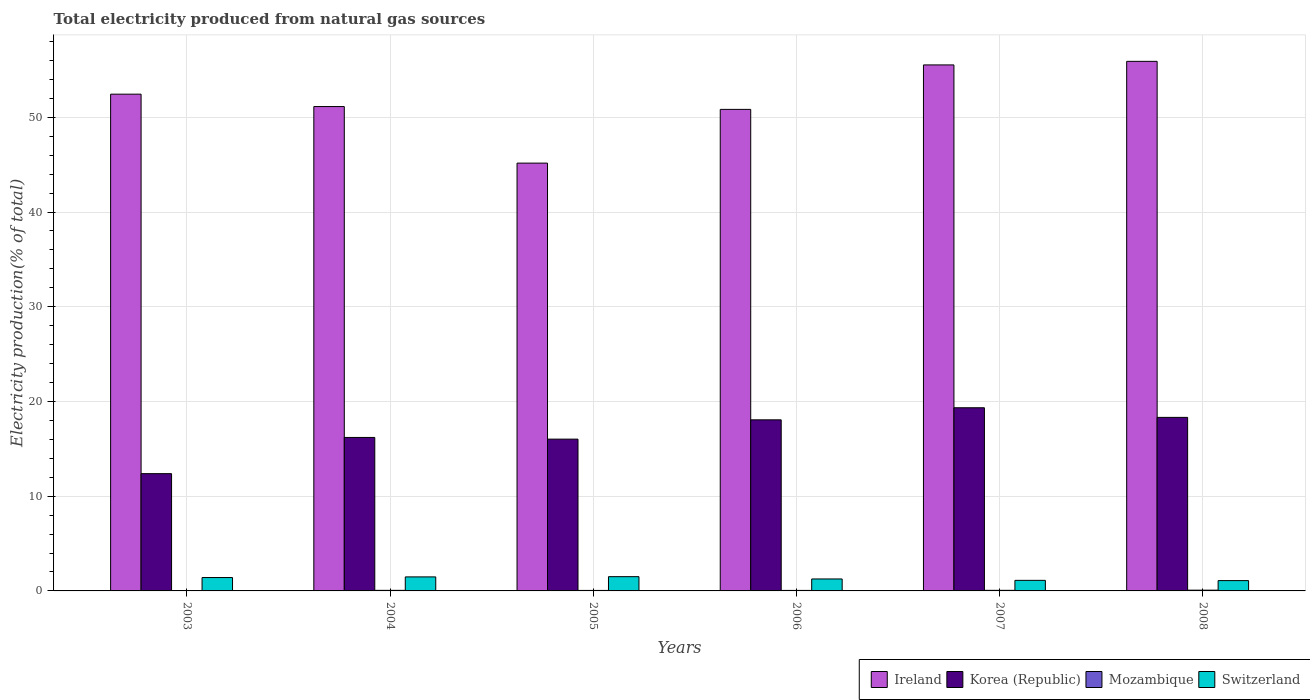How many different coloured bars are there?
Give a very brief answer. 4. What is the label of the 4th group of bars from the left?
Make the answer very short. 2006. In how many cases, is the number of bars for a given year not equal to the number of legend labels?
Ensure brevity in your answer.  0. What is the total electricity produced in Mozambique in 2008?
Your answer should be very brief. 0.08. Across all years, what is the maximum total electricity produced in Mozambique?
Your answer should be very brief. 0.08. Across all years, what is the minimum total electricity produced in Korea (Republic)?
Give a very brief answer. 12.38. What is the total total electricity produced in Ireland in the graph?
Make the answer very short. 311.02. What is the difference between the total electricity produced in Ireland in 2004 and that in 2006?
Offer a terse response. 0.3. What is the difference between the total electricity produced in Korea (Republic) in 2003 and the total electricity produced in Ireland in 2006?
Offer a terse response. -38.46. What is the average total electricity produced in Mozambique per year?
Provide a succinct answer. 0.06. In the year 2005, what is the difference between the total electricity produced in Switzerland and total electricity produced in Korea (Republic)?
Give a very brief answer. -14.52. In how many years, is the total electricity produced in Ireland greater than 42 %?
Provide a short and direct response. 6. What is the ratio of the total electricity produced in Korea (Republic) in 2003 to that in 2005?
Your answer should be compact. 0.77. What is the difference between the highest and the second highest total electricity produced in Ireland?
Ensure brevity in your answer.  0.38. What is the difference between the highest and the lowest total electricity produced in Ireland?
Ensure brevity in your answer.  10.74. Is it the case that in every year, the sum of the total electricity produced in Switzerland and total electricity produced in Ireland is greater than the sum of total electricity produced in Korea (Republic) and total electricity produced in Mozambique?
Offer a terse response. Yes. What does the 1st bar from the left in 2003 represents?
Give a very brief answer. Ireland. What does the 1st bar from the right in 2004 represents?
Offer a terse response. Switzerland. Is it the case that in every year, the sum of the total electricity produced in Korea (Republic) and total electricity produced in Switzerland is greater than the total electricity produced in Mozambique?
Make the answer very short. Yes. How many bars are there?
Give a very brief answer. 24. Does the graph contain grids?
Offer a terse response. Yes. What is the title of the graph?
Make the answer very short. Total electricity produced from natural gas sources. Does "Germany" appear as one of the legend labels in the graph?
Provide a succinct answer. No. What is the label or title of the X-axis?
Make the answer very short. Years. What is the Electricity production(% of total) in Ireland in 2003?
Give a very brief answer. 52.44. What is the Electricity production(% of total) of Korea (Republic) in 2003?
Offer a very short reply. 12.38. What is the Electricity production(% of total) of Mozambique in 2003?
Your answer should be very brief. 0.03. What is the Electricity production(% of total) of Switzerland in 2003?
Provide a succinct answer. 1.41. What is the Electricity production(% of total) of Ireland in 2004?
Offer a very short reply. 51.14. What is the Electricity production(% of total) in Korea (Republic) in 2004?
Give a very brief answer. 16.2. What is the Electricity production(% of total) in Mozambique in 2004?
Keep it short and to the point. 0.06. What is the Electricity production(% of total) in Switzerland in 2004?
Offer a very short reply. 1.48. What is the Electricity production(% of total) in Ireland in 2005?
Provide a short and direct response. 45.17. What is the Electricity production(% of total) in Korea (Republic) in 2005?
Keep it short and to the point. 16.02. What is the Electricity production(% of total) in Mozambique in 2005?
Make the answer very short. 0.05. What is the Electricity production(% of total) in Switzerland in 2005?
Offer a terse response. 1.51. What is the Electricity production(% of total) of Ireland in 2006?
Offer a terse response. 50.84. What is the Electricity production(% of total) of Korea (Republic) in 2006?
Offer a very short reply. 18.06. What is the Electricity production(% of total) of Mozambique in 2006?
Provide a succinct answer. 0.05. What is the Electricity production(% of total) in Switzerland in 2006?
Your response must be concise. 1.26. What is the Electricity production(% of total) in Ireland in 2007?
Your response must be concise. 55.53. What is the Electricity production(% of total) of Korea (Republic) in 2007?
Ensure brevity in your answer.  19.34. What is the Electricity production(% of total) of Mozambique in 2007?
Offer a terse response. 0.06. What is the Electricity production(% of total) in Switzerland in 2007?
Ensure brevity in your answer.  1.12. What is the Electricity production(% of total) in Ireland in 2008?
Offer a terse response. 55.91. What is the Electricity production(% of total) of Korea (Republic) in 2008?
Your answer should be very brief. 18.32. What is the Electricity production(% of total) of Mozambique in 2008?
Give a very brief answer. 0.08. What is the Electricity production(% of total) of Switzerland in 2008?
Keep it short and to the point. 1.09. Across all years, what is the maximum Electricity production(% of total) in Ireland?
Offer a terse response. 55.91. Across all years, what is the maximum Electricity production(% of total) of Korea (Republic)?
Your answer should be compact. 19.34. Across all years, what is the maximum Electricity production(% of total) in Mozambique?
Offer a very short reply. 0.08. Across all years, what is the maximum Electricity production(% of total) of Switzerland?
Keep it short and to the point. 1.51. Across all years, what is the minimum Electricity production(% of total) of Ireland?
Make the answer very short. 45.17. Across all years, what is the minimum Electricity production(% of total) of Korea (Republic)?
Provide a succinct answer. 12.38. Across all years, what is the minimum Electricity production(% of total) of Mozambique?
Ensure brevity in your answer.  0.03. Across all years, what is the minimum Electricity production(% of total) of Switzerland?
Make the answer very short. 1.09. What is the total Electricity production(% of total) in Ireland in the graph?
Give a very brief answer. 311.02. What is the total Electricity production(% of total) of Korea (Republic) in the graph?
Give a very brief answer. 100.33. What is the total Electricity production(% of total) of Mozambique in the graph?
Your answer should be compact. 0.34. What is the total Electricity production(% of total) in Switzerland in the graph?
Your response must be concise. 7.87. What is the difference between the Electricity production(% of total) in Ireland in 2003 and that in 2004?
Offer a terse response. 1.31. What is the difference between the Electricity production(% of total) of Korea (Republic) in 2003 and that in 2004?
Ensure brevity in your answer.  -3.82. What is the difference between the Electricity production(% of total) in Mozambique in 2003 and that in 2004?
Provide a succinct answer. -0.03. What is the difference between the Electricity production(% of total) of Switzerland in 2003 and that in 2004?
Your answer should be very brief. -0.07. What is the difference between the Electricity production(% of total) of Ireland in 2003 and that in 2005?
Your answer should be very brief. 7.28. What is the difference between the Electricity production(% of total) in Korea (Republic) in 2003 and that in 2005?
Make the answer very short. -3.64. What is the difference between the Electricity production(% of total) of Mozambique in 2003 and that in 2005?
Offer a very short reply. -0.03. What is the difference between the Electricity production(% of total) of Switzerland in 2003 and that in 2005?
Keep it short and to the point. -0.09. What is the difference between the Electricity production(% of total) of Ireland in 2003 and that in 2006?
Offer a very short reply. 1.61. What is the difference between the Electricity production(% of total) in Korea (Republic) in 2003 and that in 2006?
Offer a very short reply. -5.68. What is the difference between the Electricity production(% of total) in Mozambique in 2003 and that in 2006?
Your response must be concise. -0.03. What is the difference between the Electricity production(% of total) in Switzerland in 2003 and that in 2006?
Keep it short and to the point. 0.15. What is the difference between the Electricity production(% of total) in Ireland in 2003 and that in 2007?
Your answer should be very brief. -3.09. What is the difference between the Electricity production(% of total) in Korea (Republic) in 2003 and that in 2007?
Offer a very short reply. -6.96. What is the difference between the Electricity production(% of total) in Mozambique in 2003 and that in 2007?
Your answer should be compact. -0.03. What is the difference between the Electricity production(% of total) of Switzerland in 2003 and that in 2007?
Your answer should be compact. 0.3. What is the difference between the Electricity production(% of total) of Ireland in 2003 and that in 2008?
Your answer should be very brief. -3.46. What is the difference between the Electricity production(% of total) in Korea (Republic) in 2003 and that in 2008?
Offer a very short reply. -5.94. What is the difference between the Electricity production(% of total) in Mozambique in 2003 and that in 2008?
Provide a succinct answer. -0.05. What is the difference between the Electricity production(% of total) in Switzerland in 2003 and that in 2008?
Make the answer very short. 0.32. What is the difference between the Electricity production(% of total) of Ireland in 2004 and that in 2005?
Keep it short and to the point. 5.97. What is the difference between the Electricity production(% of total) of Korea (Republic) in 2004 and that in 2005?
Your response must be concise. 0.18. What is the difference between the Electricity production(% of total) of Mozambique in 2004 and that in 2005?
Offer a terse response. 0.01. What is the difference between the Electricity production(% of total) in Switzerland in 2004 and that in 2005?
Your answer should be very brief. -0.03. What is the difference between the Electricity production(% of total) of Ireland in 2004 and that in 2006?
Your response must be concise. 0.3. What is the difference between the Electricity production(% of total) in Korea (Republic) in 2004 and that in 2006?
Give a very brief answer. -1.86. What is the difference between the Electricity production(% of total) of Mozambique in 2004 and that in 2006?
Make the answer very short. 0.01. What is the difference between the Electricity production(% of total) in Switzerland in 2004 and that in 2006?
Offer a terse response. 0.22. What is the difference between the Electricity production(% of total) of Ireland in 2004 and that in 2007?
Offer a very short reply. -4.4. What is the difference between the Electricity production(% of total) in Korea (Republic) in 2004 and that in 2007?
Give a very brief answer. -3.14. What is the difference between the Electricity production(% of total) of Mozambique in 2004 and that in 2007?
Provide a short and direct response. -0. What is the difference between the Electricity production(% of total) of Switzerland in 2004 and that in 2007?
Keep it short and to the point. 0.36. What is the difference between the Electricity production(% of total) of Ireland in 2004 and that in 2008?
Provide a short and direct response. -4.77. What is the difference between the Electricity production(% of total) in Korea (Republic) in 2004 and that in 2008?
Offer a very short reply. -2.12. What is the difference between the Electricity production(% of total) of Mozambique in 2004 and that in 2008?
Keep it short and to the point. -0.02. What is the difference between the Electricity production(% of total) in Switzerland in 2004 and that in 2008?
Provide a succinct answer. 0.39. What is the difference between the Electricity production(% of total) in Ireland in 2005 and that in 2006?
Your answer should be compact. -5.67. What is the difference between the Electricity production(% of total) in Korea (Republic) in 2005 and that in 2006?
Offer a terse response. -2.04. What is the difference between the Electricity production(% of total) in Mozambique in 2005 and that in 2006?
Make the answer very short. -0. What is the difference between the Electricity production(% of total) of Switzerland in 2005 and that in 2006?
Provide a short and direct response. 0.24. What is the difference between the Electricity production(% of total) in Ireland in 2005 and that in 2007?
Your response must be concise. -10.37. What is the difference between the Electricity production(% of total) of Korea (Republic) in 2005 and that in 2007?
Keep it short and to the point. -3.31. What is the difference between the Electricity production(% of total) in Mozambique in 2005 and that in 2007?
Ensure brevity in your answer.  -0.01. What is the difference between the Electricity production(% of total) in Switzerland in 2005 and that in 2007?
Offer a very short reply. 0.39. What is the difference between the Electricity production(% of total) in Ireland in 2005 and that in 2008?
Provide a short and direct response. -10.74. What is the difference between the Electricity production(% of total) in Korea (Republic) in 2005 and that in 2008?
Make the answer very short. -2.3. What is the difference between the Electricity production(% of total) of Mozambique in 2005 and that in 2008?
Your response must be concise. -0.03. What is the difference between the Electricity production(% of total) of Switzerland in 2005 and that in 2008?
Provide a succinct answer. 0.42. What is the difference between the Electricity production(% of total) in Ireland in 2006 and that in 2007?
Keep it short and to the point. -4.69. What is the difference between the Electricity production(% of total) in Korea (Republic) in 2006 and that in 2007?
Offer a very short reply. -1.28. What is the difference between the Electricity production(% of total) of Mozambique in 2006 and that in 2007?
Provide a short and direct response. -0.01. What is the difference between the Electricity production(% of total) of Switzerland in 2006 and that in 2007?
Offer a very short reply. 0.15. What is the difference between the Electricity production(% of total) in Ireland in 2006 and that in 2008?
Offer a terse response. -5.07. What is the difference between the Electricity production(% of total) in Korea (Republic) in 2006 and that in 2008?
Your answer should be compact. -0.26. What is the difference between the Electricity production(% of total) of Mozambique in 2006 and that in 2008?
Offer a very short reply. -0.03. What is the difference between the Electricity production(% of total) in Switzerland in 2006 and that in 2008?
Ensure brevity in your answer.  0.17. What is the difference between the Electricity production(% of total) in Ireland in 2007 and that in 2008?
Give a very brief answer. -0.38. What is the difference between the Electricity production(% of total) in Korea (Republic) in 2007 and that in 2008?
Offer a terse response. 1.02. What is the difference between the Electricity production(% of total) of Mozambique in 2007 and that in 2008?
Provide a short and direct response. -0.02. What is the difference between the Electricity production(% of total) of Switzerland in 2007 and that in 2008?
Offer a terse response. 0.03. What is the difference between the Electricity production(% of total) of Ireland in 2003 and the Electricity production(% of total) of Korea (Republic) in 2004?
Give a very brief answer. 36.24. What is the difference between the Electricity production(% of total) of Ireland in 2003 and the Electricity production(% of total) of Mozambique in 2004?
Provide a succinct answer. 52.38. What is the difference between the Electricity production(% of total) of Ireland in 2003 and the Electricity production(% of total) of Switzerland in 2004?
Make the answer very short. 50.96. What is the difference between the Electricity production(% of total) of Korea (Republic) in 2003 and the Electricity production(% of total) of Mozambique in 2004?
Keep it short and to the point. 12.32. What is the difference between the Electricity production(% of total) of Korea (Republic) in 2003 and the Electricity production(% of total) of Switzerland in 2004?
Offer a very short reply. 10.9. What is the difference between the Electricity production(% of total) in Mozambique in 2003 and the Electricity production(% of total) in Switzerland in 2004?
Your answer should be compact. -1.45. What is the difference between the Electricity production(% of total) of Ireland in 2003 and the Electricity production(% of total) of Korea (Republic) in 2005?
Give a very brief answer. 36.42. What is the difference between the Electricity production(% of total) in Ireland in 2003 and the Electricity production(% of total) in Mozambique in 2005?
Your answer should be compact. 52.39. What is the difference between the Electricity production(% of total) of Ireland in 2003 and the Electricity production(% of total) of Switzerland in 2005?
Provide a succinct answer. 50.94. What is the difference between the Electricity production(% of total) of Korea (Republic) in 2003 and the Electricity production(% of total) of Mozambique in 2005?
Give a very brief answer. 12.33. What is the difference between the Electricity production(% of total) of Korea (Republic) in 2003 and the Electricity production(% of total) of Switzerland in 2005?
Your response must be concise. 10.88. What is the difference between the Electricity production(% of total) in Mozambique in 2003 and the Electricity production(% of total) in Switzerland in 2005?
Your answer should be very brief. -1.48. What is the difference between the Electricity production(% of total) in Ireland in 2003 and the Electricity production(% of total) in Korea (Republic) in 2006?
Give a very brief answer. 34.38. What is the difference between the Electricity production(% of total) of Ireland in 2003 and the Electricity production(% of total) of Mozambique in 2006?
Make the answer very short. 52.39. What is the difference between the Electricity production(% of total) in Ireland in 2003 and the Electricity production(% of total) in Switzerland in 2006?
Your answer should be compact. 51.18. What is the difference between the Electricity production(% of total) of Korea (Republic) in 2003 and the Electricity production(% of total) of Mozambique in 2006?
Make the answer very short. 12.33. What is the difference between the Electricity production(% of total) in Korea (Republic) in 2003 and the Electricity production(% of total) in Switzerland in 2006?
Your response must be concise. 11.12. What is the difference between the Electricity production(% of total) of Mozambique in 2003 and the Electricity production(% of total) of Switzerland in 2006?
Offer a very short reply. -1.24. What is the difference between the Electricity production(% of total) of Ireland in 2003 and the Electricity production(% of total) of Korea (Republic) in 2007?
Your answer should be compact. 33.11. What is the difference between the Electricity production(% of total) in Ireland in 2003 and the Electricity production(% of total) in Mozambique in 2007?
Offer a terse response. 52.38. What is the difference between the Electricity production(% of total) of Ireland in 2003 and the Electricity production(% of total) of Switzerland in 2007?
Keep it short and to the point. 51.33. What is the difference between the Electricity production(% of total) of Korea (Republic) in 2003 and the Electricity production(% of total) of Mozambique in 2007?
Offer a very short reply. 12.32. What is the difference between the Electricity production(% of total) of Korea (Republic) in 2003 and the Electricity production(% of total) of Switzerland in 2007?
Give a very brief answer. 11.27. What is the difference between the Electricity production(% of total) in Mozambique in 2003 and the Electricity production(% of total) in Switzerland in 2007?
Your answer should be very brief. -1.09. What is the difference between the Electricity production(% of total) in Ireland in 2003 and the Electricity production(% of total) in Korea (Republic) in 2008?
Ensure brevity in your answer.  34.12. What is the difference between the Electricity production(% of total) of Ireland in 2003 and the Electricity production(% of total) of Mozambique in 2008?
Your answer should be compact. 52.36. What is the difference between the Electricity production(% of total) in Ireland in 2003 and the Electricity production(% of total) in Switzerland in 2008?
Offer a terse response. 51.35. What is the difference between the Electricity production(% of total) in Korea (Republic) in 2003 and the Electricity production(% of total) in Mozambique in 2008?
Make the answer very short. 12.3. What is the difference between the Electricity production(% of total) in Korea (Republic) in 2003 and the Electricity production(% of total) in Switzerland in 2008?
Your answer should be very brief. 11.29. What is the difference between the Electricity production(% of total) of Mozambique in 2003 and the Electricity production(% of total) of Switzerland in 2008?
Give a very brief answer. -1.06. What is the difference between the Electricity production(% of total) in Ireland in 2004 and the Electricity production(% of total) in Korea (Republic) in 2005?
Keep it short and to the point. 35.11. What is the difference between the Electricity production(% of total) of Ireland in 2004 and the Electricity production(% of total) of Mozambique in 2005?
Offer a terse response. 51.08. What is the difference between the Electricity production(% of total) in Ireland in 2004 and the Electricity production(% of total) in Switzerland in 2005?
Your response must be concise. 49.63. What is the difference between the Electricity production(% of total) of Korea (Republic) in 2004 and the Electricity production(% of total) of Mozambique in 2005?
Make the answer very short. 16.15. What is the difference between the Electricity production(% of total) of Korea (Republic) in 2004 and the Electricity production(% of total) of Switzerland in 2005?
Provide a succinct answer. 14.7. What is the difference between the Electricity production(% of total) of Mozambique in 2004 and the Electricity production(% of total) of Switzerland in 2005?
Offer a terse response. -1.45. What is the difference between the Electricity production(% of total) in Ireland in 2004 and the Electricity production(% of total) in Korea (Republic) in 2006?
Keep it short and to the point. 33.07. What is the difference between the Electricity production(% of total) in Ireland in 2004 and the Electricity production(% of total) in Mozambique in 2006?
Give a very brief answer. 51.08. What is the difference between the Electricity production(% of total) of Ireland in 2004 and the Electricity production(% of total) of Switzerland in 2006?
Provide a succinct answer. 49.87. What is the difference between the Electricity production(% of total) in Korea (Republic) in 2004 and the Electricity production(% of total) in Mozambique in 2006?
Make the answer very short. 16.15. What is the difference between the Electricity production(% of total) in Korea (Republic) in 2004 and the Electricity production(% of total) in Switzerland in 2006?
Provide a succinct answer. 14.94. What is the difference between the Electricity production(% of total) in Mozambique in 2004 and the Electricity production(% of total) in Switzerland in 2006?
Make the answer very short. -1.2. What is the difference between the Electricity production(% of total) in Ireland in 2004 and the Electricity production(% of total) in Korea (Republic) in 2007?
Provide a succinct answer. 31.8. What is the difference between the Electricity production(% of total) of Ireland in 2004 and the Electricity production(% of total) of Mozambique in 2007?
Make the answer very short. 51.07. What is the difference between the Electricity production(% of total) of Ireland in 2004 and the Electricity production(% of total) of Switzerland in 2007?
Provide a short and direct response. 50.02. What is the difference between the Electricity production(% of total) in Korea (Republic) in 2004 and the Electricity production(% of total) in Mozambique in 2007?
Give a very brief answer. 16.14. What is the difference between the Electricity production(% of total) of Korea (Republic) in 2004 and the Electricity production(% of total) of Switzerland in 2007?
Your answer should be compact. 15.09. What is the difference between the Electricity production(% of total) of Mozambique in 2004 and the Electricity production(% of total) of Switzerland in 2007?
Provide a succinct answer. -1.06. What is the difference between the Electricity production(% of total) of Ireland in 2004 and the Electricity production(% of total) of Korea (Republic) in 2008?
Give a very brief answer. 32.82. What is the difference between the Electricity production(% of total) in Ireland in 2004 and the Electricity production(% of total) in Mozambique in 2008?
Offer a very short reply. 51.06. What is the difference between the Electricity production(% of total) in Ireland in 2004 and the Electricity production(% of total) in Switzerland in 2008?
Make the answer very short. 50.05. What is the difference between the Electricity production(% of total) of Korea (Republic) in 2004 and the Electricity production(% of total) of Mozambique in 2008?
Provide a succinct answer. 16.12. What is the difference between the Electricity production(% of total) of Korea (Republic) in 2004 and the Electricity production(% of total) of Switzerland in 2008?
Your answer should be very brief. 15.11. What is the difference between the Electricity production(% of total) of Mozambique in 2004 and the Electricity production(% of total) of Switzerland in 2008?
Keep it short and to the point. -1.03. What is the difference between the Electricity production(% of total) of Ireland in 2005 and the Electricity production(% of total) of Korea (Republic) in 2006?
Offer a very short reply. 27.1. What is the difference between the Electricity production(% of total) of Ireland in 2005 and the Electricity production(% of total) of Mozambique in 2006?
Your answer should be compact. 45.11. What is the difference between the Electricity production(% of total) in Ireland in 2005 and the Electricity production(% of total) in Switzerland in 2006?
Ensure brevity in your answer.  43.9. What is the difference between the Electricity production(% of total) of Korea (Republic) in 2005 and the Electricity production(% of total) of Mozambique in 2006?
Offer a terse response. 15.97. What is the difference between the Electricity production(% of total) of Korea (Republic) in 2005 and the Electricity production(% of total) of Switzerland in 2006?
Keep it short and to the point. 14.76. What is the difference between the Electricity production(% of total) in Mozambique in 2005 and the Electricity production(% of total) in Switzerland in 2006?
Make the answer very short. -1.21. What is the difference between the Electricity production(% of total) of Ireland in 2005 and the Electricity production(% of total) of Korea (Republic) in 2007?
Your answer should be very brief. 25.83. What is the difference between the Electricity production(% of total) of Ireland in 2005 and the Electricity production(% of total) of Mozambique in 2007?
Offer a very short reply. 45.1. What is the difference between the Electricity production(% of total) in Ireland in 2005 and the Electricity production(% of total) in Switzerland in 2007?
Your answer should be very brief. 44.05. What is the difference between the Electricity production(% of total) in Korea (Republic) in 2005 and the Electricity production(% of total) in Mozambique in 2007?
Your response must be concise. 15.96. What is the difference between the Electricity production(% of total) in Korea (Republic) in 2005 and the Electricity production(% of total) in Switzerland in 2007?
Your answer should be compact. 14.91. What is the difference between the Electricity production(% of total) of Mozambique in 2005 and the Electricity production(% of total) of Switzerland in 2007?
Offer a very short reply. -1.06. What is the difference between the Electricity production(% of total) of Ireland in 2005 and the Electricity production(% of total) of Korea (Republic) in 2008?
Your response must be concise. 26.84. What is the difference between the Electricity production(% of total) in Ireland in 2005 and the Electricity production(% of total) in Mozambique in 2008?
Provide a short and direct response. 45.09. What is the difference between the Electricity production(% of total) in Ireland in 2005 and the Electricity production(% of total) in Switzerland in 2008?
Keep it short and to the point. 44.08. What is the difference between the Electricity production(% of total) of Korea (Republic) in 2005 and the Electricity production(% of total) of Mozambique in 2008?
Make the answer very short. 15.94. What is the difference between the Electricity production(% of total) of Korea (Republic) in 2005 and the Electricity production(% of total) of Switzerland in 2008?
Give a very brief answer. 14.94. What is the difference between the Electricity production(% of total) of Mozambique in 2005 and the Electricity production(% of total) of Switzerland in 2008?
Provide a short and direct response. -1.04. What is the difference between the Electricity production(% of total) in Ireland in 2006 and the Electricity production(% of total) in Korea (Republic) in 2007?
Your answer should be compact. 31.5. What is the difference between the Electricity production(% of total) in Ireland in 2006 and the Electricity production(% of total) in Mozambique in 2007?
Your response must be concise. 50.77. What is the difference between the Electricity production(% of total) in Ireland in 2006 and the Electricity production(% of total) in Switzerland in 2007?
Offer a very short reply. 49.72. What is the difference between the Electricity production(% of total) in Korea (Republic) in 2006 and the Electricity production(% of total) in Mozambique in 2007?
Offer a very short reply. 18. What is the difference between the Electricity production(% of total) in Korea (Republic) in 2006 and the Electricity production(% of total) in Switzerland in 2007?
Give a very brief answer. 16.95. What is the difference between the Electricity production(% of total) of Mozambique in 2006 and the Electricity production(% of total) of Switzerland in 2007?
Provide a short and direct response. -1.06. What is the difference between the Electricity production(% of total) in Ireland in 2006 and the Electricity production(% of total) in Korea (Republic) in 2008?
Provide a short and direct response. 32.52. What is the difference between the Electricity production(% of total) in Ireland in 2006 and the Electricity production(% of total) in Mozambique in 2008?
Provide a short and direct response. 50.76. What is the difference between the Electricity production(% of total) in Ireland in 2006 and the Electricity production(% of total) in Switzerland in 2008?
Give a very brief answer. 49.75. What is the difference between the Electricity production(% of total) in Korea (Republic) in 2006 and the Electricity production(% of total) in Mozambique in 2008?
Offer a very short reply. 17.98. What is the difference between the Electricity production(% of total) of Korea (Republic) in 2006 and the Electricity production(% of total) of Switzerland in 2008?
Your answer should be very brief. 16.97. What is the difference between the Electricity production(% of total) of Mozambique in 2006 and the Electricity production(% of total) of Switzerland in 2008?
Your answer should be compact. -1.03. What is the difference between the Electricity production(% of total) in Ireland in 2007 and the Electricity production(% of total) in Korea (Republic) in 2008?
Provide a succinct answer. 37.21. What is the difference between the Electricity production(% of total) in Ireland in 2007 and the Electricity production(% of total) in Mozambique in 2008?
Give a very brief answer. 55.45. What is the difference between the Electricity production(% of total) of Ireland in 2007 and the Electricity production(% of total) of Switzerland in 2008?
Keep it short and to the point. 54.44. What is the difference between the Electricity production(% of total) in Korea (Republic) in 2007 and the Electricity production(% of total) in Mozambique in 2008?
Provide a short and direct response. 19.26. What is the difference between the Electricity production(% of total) in Korea (Republic) in 2007 and the Electricity production(% of total) in Switzerland in 2008?
Provide a succinct answer. 18.25. What is the difference between the Electricity production(% of total) of Mozambique in 2007 and the Electricity production(% of total) of Switzerland in 2008?
Provide a short and direct response. -1.03. What is the average Electricity production(% of total) of Ireland per year?
Your answer should be very brief. 51.84. What is the average Electricity production(% of total) in Korea (Republic) per year?
Give a very brief answer. 16.72. What is the average Electricity production(% of total) in Mozambique per year?
Your response must be concise. 0.06. What is the average Electricity production(% of total) of Switzerland per year?
Offer a very short reply. 1.31. In the year 2003, what is the difference between the Electricity production(% of total) in Ireland and Electricity production(% of total) in Korea (Republic)?
Give a very brief answer. 40.06. In the year 2003, what is the difference between the Electricity production(% of total) in Ireland and Electricity production(% of total) in Mozambique?
Provide a succinct answer. 52.42. In the year 2003, what is the difference between the Electricity production(% of total) in Ireland and Electricity production(% of total) in Switzerland?
Ensure brevity in your answer.  51.03. In the year 2003, what is the difference between the Electricity production(% of total) of Korea (Republic) and Electricity production(% of total) of Mozambique?
Make the answer very short. 12.35. In the year 2003, what is the difference between the Electricity production(% of total) of Korea (Republic) and Electricity production(% of total) of Switzerland?
Give a very brief answer. 10.97. In the year 2003, what is the difference between the Electricity production(% of total) of Mozambique and Electricity production(% of total) of Switzerland?
Ensure brevity in your answer.  -1.39. In the year 2004, what is the difference between the Electricity production(% of total) of Ireland and Electricity production(% of total) of Korea (Republic)?
Offer a terse response. 34.93. In the year 2004, what is the difference between the Electricity production(% of total) of Ireland and Electricity production(% of total) of Mozambique?
Make the answer very short. 51.08. In the year 2004, what is the difference between the Electricity production(% of total) in Ireland and Electricity production(% of total) in Switzerland?
Offer a terse response. 49.66. In the year 2004, what is the difference between the Electricity production(% of total) of Korea (Republic) and Electricity production(% of total) of Mozambique?
Ensure brevity in your answer.  16.14. In the year 2004, what is the difference between the Electricity production(% of total) in Korea (Republic) and Electricity production(% of total) in Switzerland?
Your response must be concise. 14.72. In the year 2004, what is the difference between the Electricity production(% of total) of Mozambique and Electricity production(% of total) of Switzerland?
Your answer should be compact. -1.42. In the year 2005, what is the difference between the Electricity production(% of total) in Ireland and Electricity production(% of total) in Korea (Republic)?
Provide a succinct answer. 29.14. In the year 2005, what is the difference between the Electricity production(% of total) of Ireland and Electricity production(% of total) of Mozambique?
Offer a terse response. 45.11. In the year 2005, what is the difference between the Electricity production(% of total) in Ireland and Electricity production(% of total) in Switzerland?
Provide a succinct answer. 43.66. In the year 2005, what is the difference between the Electricity production(% of total) of Korea (Republic) and Electricity production(% of total) of Mozambique?
Your answer should be compact. 15.97. In the year 2005, what is the difference between the Electricity production(% of total) in Korea (Republic) and Electricity production(% of total) in Switzerland?
Offer a terse response. 14.52. In the year 2005, what is the difference between the Electricity production(% of total) in Mozambique and Electricity production(% of total) in Switzerland?
Give a very brief answer. -1.45. In the year 2006, what is the difference between the Electricity production(% of total) in Ireland and Electricity production(% of total) in Korea (Republic)?
Ensure brevity in your answer.  32.78. In the year 2006, what is the difference between the Electricity production(% of total) of Ireland and Electricity production(% of total) of Mozambique?
Offer a very short reply. 50.78. In the year 2006, what is the difference between the Electricity production(% of total) in Ireland and Electricity production(% of total) in Switzerland?
Give a very brief answer. 49.57. In the year 2006, what is the difference between the Electricity production(% of total) in Korea (Republic) and Electricity production(% of total) in Mozambique?
Provide a succinct answer. 18.01. In the year 2006, what is the difference between the Electricity production(% of total) of Korea (Republic) and Electricity production(% of total) of Switzerland?
Offer a very short reply. 16.8. In the year 2006, what is the difference between the Electricity production(% of total) of Mozambique and Electricity production(% of total) of Switzerland?
Your answer should be compact. -1.21. In the year 2007, what is the difference between the Electricity production(% of total) in Ireland and Electricity production(% of total) in Korea (Republic)?
Your response must be concise. 36.19. In the year 2007, what is the difference between the Electricity production(% of total) in Ireland and Electricity production(% of total) in Mozambique?
Ensure brevity in your answer.  55.47. In the year 2007, what is the difference between the Electricity production(% of total) in Ireland and Electricity production(% of total) in Switzerland?
Your answer should be very brief. 54.42. In the year 2007, what is the difference between the Electricity production(% of total) in Korea (Republic) and Electricity production(% of total) in Mozambique?
Your answer should be compact. 19.28. In the year 2007, what is the difference between the Electricity production(% of total) in Korea (Republic) and Electricity production(% of total) in Switzerland?
Make the answer very short. 18.22. In the year 2007, what is the difference between the Electricity production(% of total) in Mozambique and Electricity production(% of total) in Switzerland?
Provide a succinct answer. -1.05. In the year 2008, what is the difference between the Electricity production(% of total) of Ireland and Electricity production(% of total) of Korea (Republic)?
Keep it short and to the point. 37.59. In the year 2008, what is the difference between the Electricity production(% of total) in Ireland and Electricity production(% of total) in Mozambique?
Provide a short and direct response. 55.83. In the year 2008, what is the difference between the Electricity production(% of total) of Ireland and Electricity production(% of total) of Switzerland?
Your answer should be compact. 54.82. In the year 2008, what is the difference between the Electricity production(% of total) in Korea (Republic) and Electricity production(% of total) in Mozambique?
Provide a succinct answer. 18.24. In the year 2008, what is the difference between the Electricity production(% of total) in Korea (Republic) and Electricity production(% of total) in Switzerland?
Ensure brevity in your answer.  17.23. In the year 2008, what is the difference between the Electricity production(% of total) in Mozambique and Electricity production(% of total) in Switzerland?
Offer a terse response. -1.01. What is the ratio of the Electricity production(% of total) in Ireland in 2003 to that in 2004?
Offer a terse response. 1.03. What is the ratio of the Electricity production(% of total) in Korea (Republic) in 2003 to that in 2004?
Your response must be concise. 0.76. What is the ratio of the Electricity production(% of total) in Mozambique in 2003 to that in 2004?
Keep it short and to the point. 0.46. What is the ratio of the Electricity production(% of total) in Switzerland in 2003 to that in 2004?
Keep it short and to the point. 0.95. What is the ratio of the Electricity production(% of total) of Ireland in 2003 to that in 2005?
Your response must be concise. 1.16. What is the ratio of the Electricity production(% of total) in Korea (Republic) in 2003 to that in 2005?
Your answer should be compact. 0.77. What is the ratio of the Electricity production(% of total) of Mozambique in 2003 to that in 2005?
Keep it short and to the point. 0.52. What is the ratio of the Electricity production(% of total) in Switzerland in 2003 to that in 2005?
Make the answer very short. 0.94. What is the ratio of the Electricity production(% of total) in Ireland in 2003 to that in 2006?
Your answer should be very brief. 1.03. What is the ratio of the Electricity production(% of total) in Korea (Republic) in 2003 to that in 2006?
Ensure brevity in your answer.  0.69. What is the ratio of the Electricity production(% of total) of Mozambique in 2003 to that in 2006?
Provide a short and direct response. 0.51. What is the ratio of the Electricity production(% of total) in Switzerland in 2003 to that in 2006?
Provide a short and direct response. 1.12. What is the ratio of the Electricity production(% of total) in Ireland in 2003 to that in 2007?
Your answer should be very brief. 0.94. What is the ratio of the Electricity production(% of total) in Korea (Republic) in 2003 to that in 2007?
Your answer should be compact. 0.64. What is the ratio of the Electricity production(% of total) in Mozambique in 2003 to that in 2007?
Your answer should be very brief. 0.44. What is the ratio of the Electricity production(% of total) in Switzerland in 2003 to that in 2007?
Your response must be concise. 1.27. What is the ratio of the Electricity production(% of total) in Ireland in 2003 to that in 2008?
Make the answer very short. 0.94. What is the ratio of the Electricity production(% of total) in Korea (Republic) in 2003 to that in 2008?
Offer a terse response. 0.68. What is the ratio of the Electricity production(% of total) in Mozambique in 2003 to that in 2008?
Your response must be concise. 0.35. What is the ratio of the Electricity production(% of total) of Switzerland in 2003 to that in 2008?
Your answer should be very brief. 1.3. What is the ratio of the Electricity production(% of total) in Ireland in 2004 to that in 2005?
Your answer should be compact. 1.13. What is the ratio of the Electricity production(% of total) in Korea (Republic) in 2004 to that in 2005?
Offer a terse response. 1.01. What is the ratio of the Electricity production(% of total) in Mozambique in 2004 to that in 2005?
Keep it short and to the point. 1.13. What is the ratio of the Electricity production(% of total) of Switzerland in 2004 to that in 2005?
Your answer should be compact. 0.98. What is the ratio of the Electricity production(% of total) in Ireland in 2004 to that in 2006?
Ensure brevity in your answer.  1.01. What is the ratio of the Electricity production(% of total) in Korea (Republic) in 2004 to that in 2006?
Your response must be concise. 0.9. What is the ratio of the Electricity production(% of total) in Mozambique in 2004 to that in 2006?
Keep it short and to the point. 1.1. What is the ratio of the Electricity production(% of total) of Switzerland in 2004 to that in 2006?
Your answer should be very brief. 1.17. What is the ratio of the Electricity production(% of total) in Ireland in 2004 to that in 2007?
Provide a succinct answer. 0.92. What is the ratio of the Electricity production(% of total) in Korea (Republic) in 2004 to that in 2007?
Offer a terse response. 0.84. What is the ratio of the Electricity production(% of total) of Mozambique in 2004 to that in 2007?
Keep it short and to the point. 0.96. What is the ratio of the Electricity production(% of total) of Switzerland in 2004 to that in 2007?
Provide a succinct answer. 1.33. What is the ratio of the Electricity production(% of total) in Ireland in 2004 to that in 2008?
Your answer should be compact. 0.91. What is the ratio of the Electricity production(% of total) of Korea (Republic) in 2004 to that in 2008?
Give a very brief answer. 0.88. What is the ratio of the Electricity production(% of total) of Mozambique in 2004 to that in 2008?
Provide a succinct answer. 0.75. What is the ratio of the Electricity production(% of total) of Switzerland in 2004 to that in 2008?
Offer a terse response. 1.36. What is the ratio of the Electricity production(% of total) of Ireland in 2005 to that in 2006?
Offer a very short reply. 0.89. What is the ratio of the Electricity production(% of total) of Korea (Republic) in 2005 to that in 2006?
Offer a terse response. 0.89. What is the ratio of the Electricity production(% of total) in Mozambique in 2005 to that in 2006?
Provide a short and direct response. 0.97. What is the ratio of the Electricity production(% of total) of Switzerland in 2005 to that in 2006?
Offer a terse response. 1.19. What is the ratio of the Electricity production(% of total) in Ireland in 2005 to that in 2007?
Offer a terse response. 0.81. What is the ratio of the Electricity production(% of total) of Korea (Republic) in 2005 to that in 2007?
Keep it short and to the point. 0.83. What is the ratio of the Electricity production(% of total) in Mozambique in 2005 to that in 2007?
Offer a very short reply. 0.85. What is the ratio of the Electricity production(% of total) in Switzerland in 2005 to that in 2007?
Provide a short and direct response. 1.35. What is the ratio of the Electricity production(% of total) in Ireland in 2005 to that in 2008?
Provide a short and direct response. 0.81. What is the ratio of the Electricity production(% of total) in Korea (Republic) in 2005 to that in 2008?
Make the answer very short. 0.87. What is the ratio of the Electricity production(% of total) in Mozambique in 2005 to that in 2008?
Give a very brief answer. 0.66. What is the ratio of the Electricity production(% of total) of Switzerland in 2005 to that in 2008?
Your answer should be compact. 1.38. What is the ratio of the Electricity production(% of total) in Ireland in 2006 to that in 2007?
Make the answer very short. 0.92. What is the ratio of the Electricity production(% of total) in Korea (Republic) in 2006 to that in 2007?
Provide a short and direct response. 0.93. What is the ratio of the Electricity production(% of total) of Mozambique in 2006 to that in 2007?
Provide a succinct answer. 0.87. What is the ratio of the Electricity production(% of total) of Switzerland in 2006 to that in 2007?
Provide a short and direct response. 1.13. What is the ratio of the Electricity production(% of total) of Ireland in 2006 to that in 2008?
Make the answer very short. 0.91. What is the ratio of the Electricity production(% of total) in Korea (Republic) in 2006 to that in 2008?
Your response must be concise. 0.99. What is the ratio of the Electricity production(% of total) in Mozambique in 2006 to that in 2008?
Your answer should be very brief. 0.68. What is the ratio of the Electricity production(% of total) of Switzerland in 2006 to that in 2008?
Make the answer very short. 1.16. What is the ratio of the Electricity production(% of total) in Ireland in 2007 to that in 2008?
Provide a short and direct response. 0.99. What is the ratio of the Electricity production(% of total) in Korea (Republic) in 2007 to that in 2008?
Ensure brevity in your answer.  1.06. What is the ratio of the Electricity production(% of total) in Mozambique in 2007 to that in 2008?
Your answer should be very brief. 0.78. What is the ratio of the Electricity production(% of total) in Switzerland in 2007 to that in 2008?
Give a very brief answer. 1.02. What is the difference between the highest and the second highest Electricity production(% of total) of Ireland?
Give a very brief answer. 0.38. What is the difference between the highest and the second highest Electricity production(% of total) in Korea (Republic)?
Ensure brevity in your answer.  1.02. What is the difference between the highest and the second highest Electricity production(% of total) of Mozambique?
Keep it short and to the point. 0.02. What is the difference between the highest and the second highest Electricity production(% of total) of Switzerland?
Your answer should be very brief. 0.03. What is the difference between the highest and the lowest Electricity production(% of total) of Ireland?
Provide a short and direct response. 10.74. What is the difference between the highest and the lowest Electricity production(% of total) in Korea (Republic)?
Provide a short and direct response. 6.96. What is the difference between the highest and the lowest Electricity production(% of total) in Mozambique?
Keep it short and to the point. 0.05. What is the difference between the highest and the lowest Electricity production(% of total) in Switzerland?
Give a very brief answer. 0.42. 